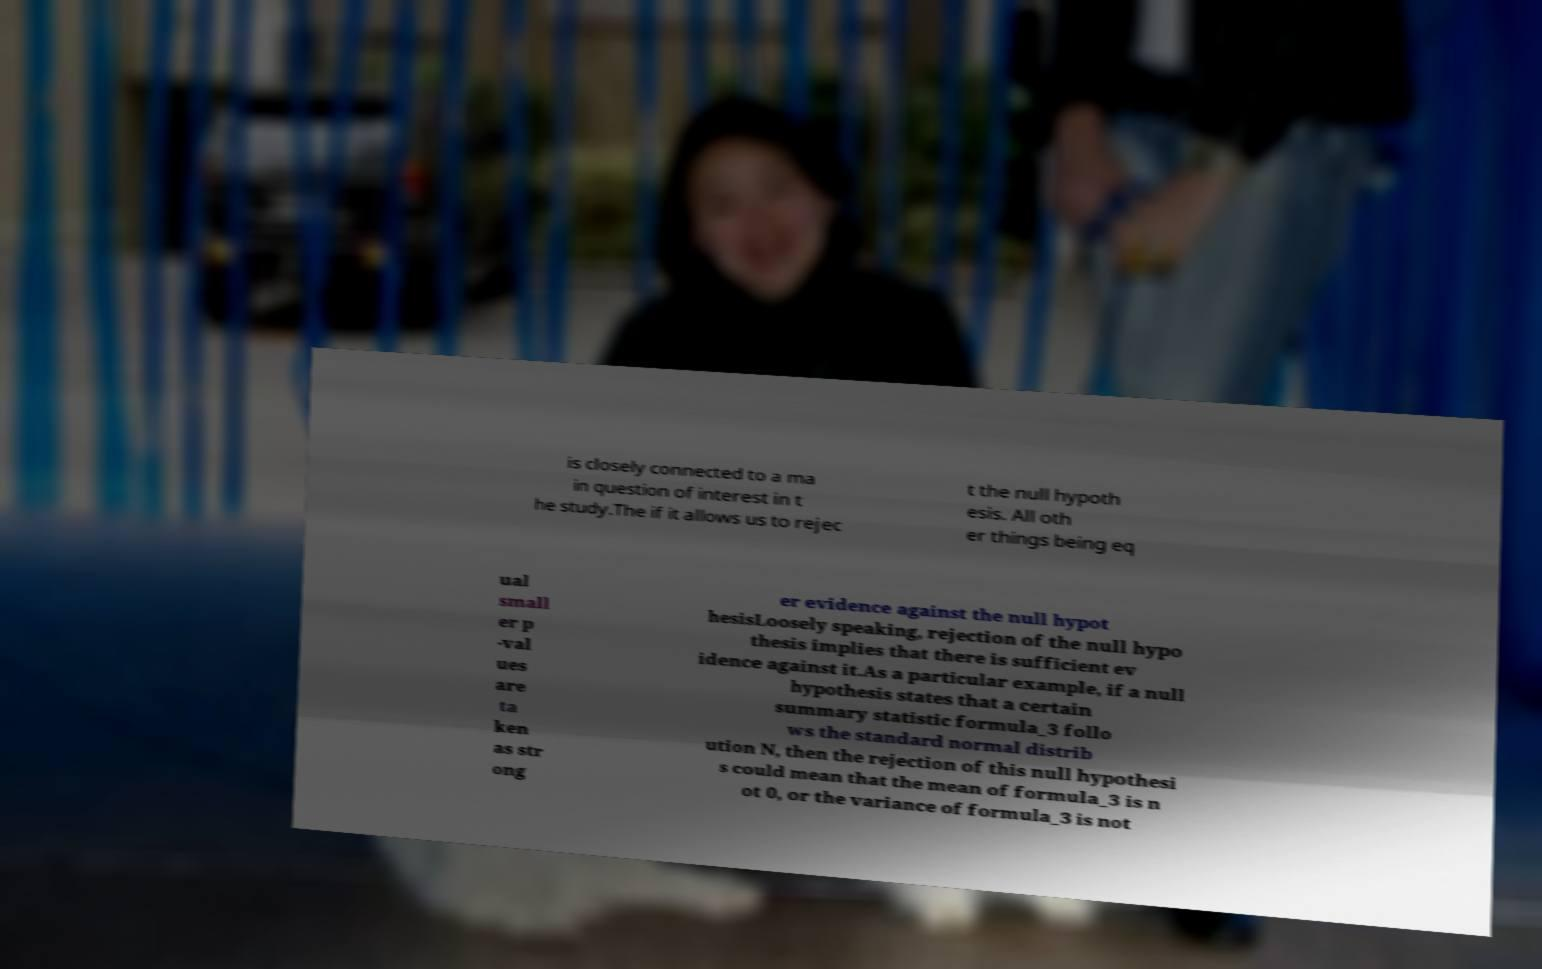Can you accurately transcribe the text from the provided image for me? is closely connected to a ma in question of interest in t he study.The if it allows us to rejec t the null hypoth esis. All oth er things being eq ual small er p -val ues are ta ken as str ong er evidence against the null hypot hesisLoosely speaking, rejection of the null hypo thesis implies that there is sufficient ev idence against it.As a particular example, if a null hypothesis states that a certain summary statistic formula_3 follo ws the standard normal distrib ution N, then the rejection of this null hypothesi s could mean that the mean of formula_3 is n ot 0, or the variance of formula_3 is not 